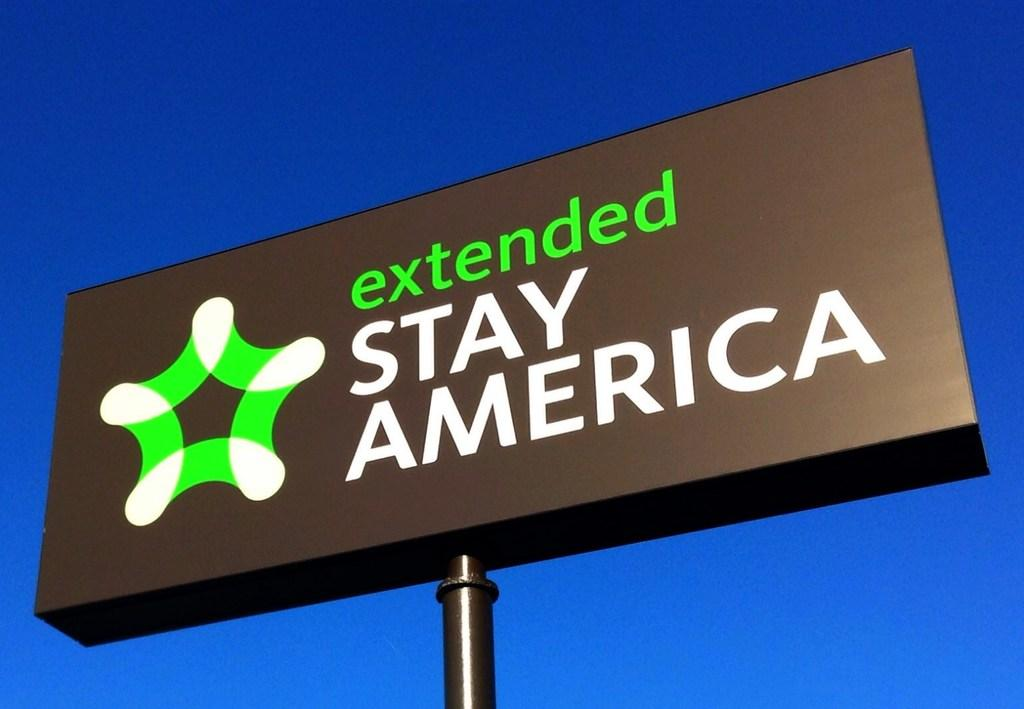<image>
Provide a brief description of the given image. A large black sign for the Extended Stay America Hotel. 